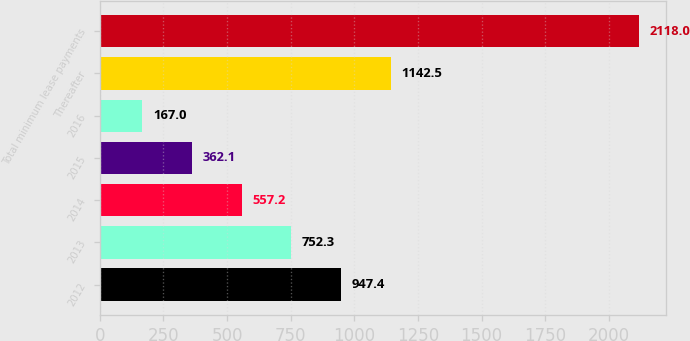Convert chart. <chart><loc_0><loc_0><loc_500><loc_500><bar_chart><fcel>2012<fcel>2013<fcel>2014<fcel>2015<fcel>2016<fcel>Thereafter<fcel>Total minimum lease payments<nl><fcel>947.4<fcel>752.3<fcel>557.2<fcel>362.1<fcel>167<fcel>1142.5<fcel>2118<nl></chart> 